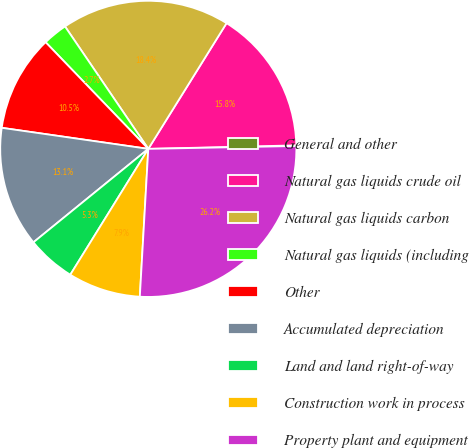Convert chart to OTSL. <chart><loc_0><loc_0><loc_500><loc_500><pie_chart><fcel>General and other<fcel>Natural gas liquids crude oil<fcel>Natural gas liquids carbon<fcel>Natural gas liquids (including<fcel>Other<fcel>Accumulated depreciation<fcel>Land and land right-of-way<fcel>Construction work in process<fcel>Property plant and equipment<nl><fcel>0.07%<fcel>15.76%<fcel>18.37%<fcel>2.69%<fcel>10.53%<fcel>13.14%<fcel>5.3%<fcel>7.92%<fcel>26.22%<nl></chart> 